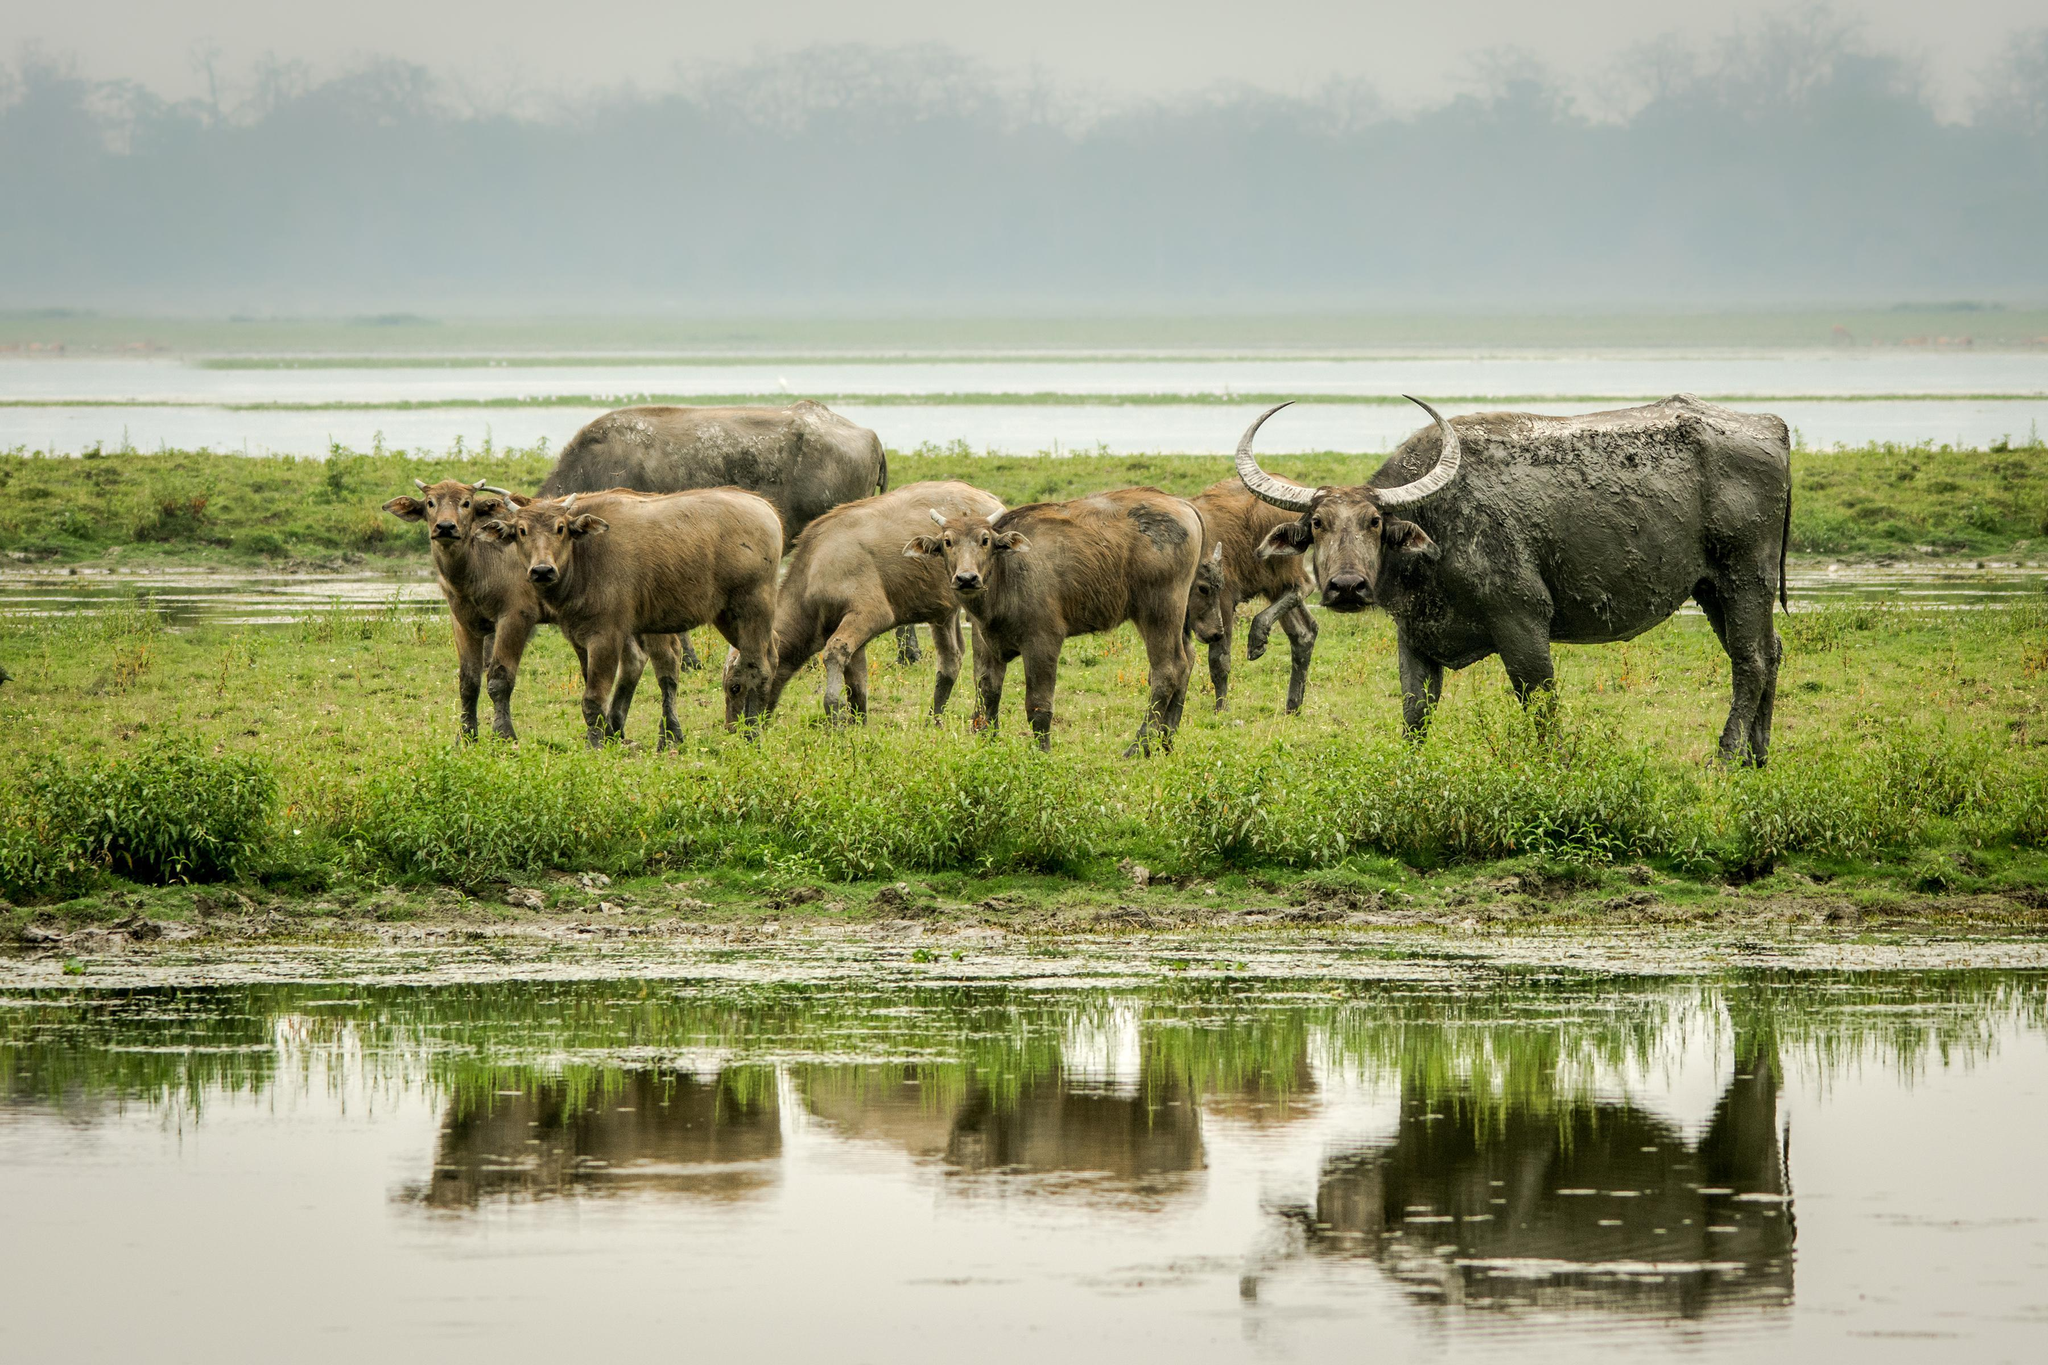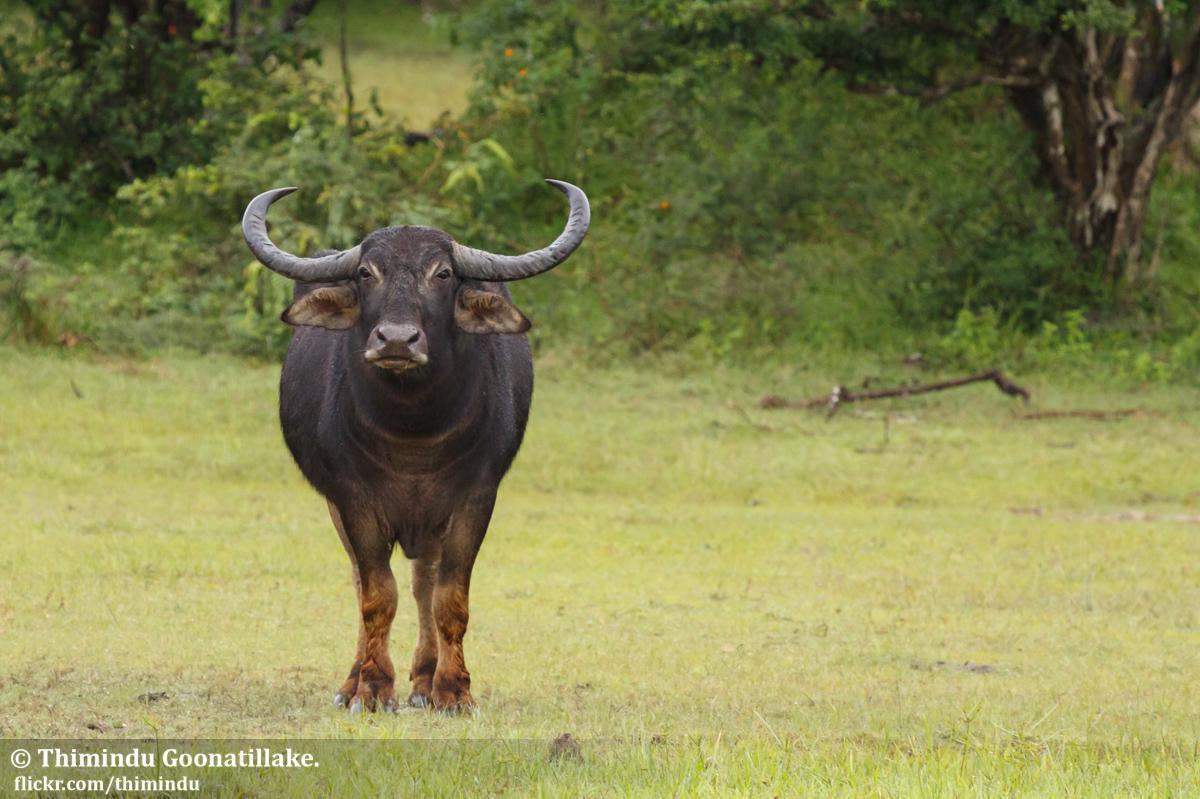The first image is the image on the left, the second image is the image on the right. Evaluate the accuracy of this statement regarding the images: "An area of water is present in one image of water buffalo.". Is it true? Answer yes or no. Yes. 